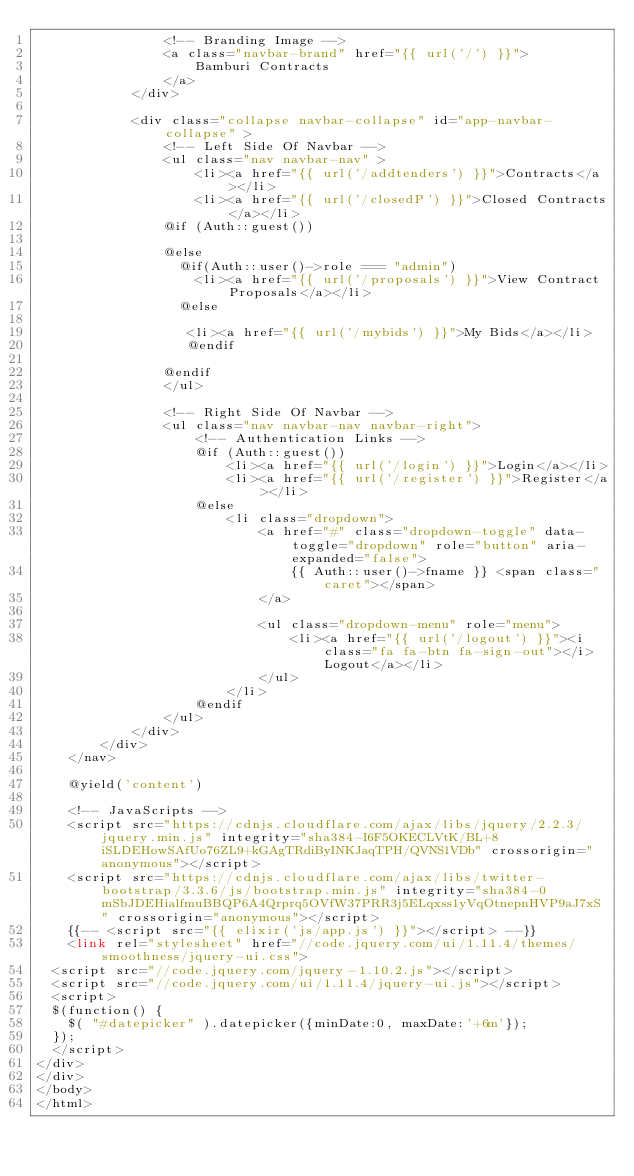Convert code to text. <code><loc_0><loc_0><loc_500><loc_500><_PHP_>                <!-- Branding Image -->
                <a class="navbar-brand" href="{{ url('/') }}">
                    Bamburi Contracts
                </a>
            </div>

            <div class="collapse navbar-collapse" id="app-navbar-collapse" >
                <!-- Left Side Of Navbar -->
                <ul class="nav navbar-nav" >
                    <li><a href="{{ url('/addtenders') }}">Contracts</a></li>
                    <li><a href="{{ url('/closedP') }}">Closed Contracts</a></li>
                @if (Auth::guest())

                @else
                  @if(Auth::user()->role === "admin")
                    <li><a href="{{ url('/proposals') }}">View Contract Proposals</a></li>
                  @else

                   <li><a href="{{ url('/mybids') }}">My Bids</a></li>
                   @endif

                @endif
                </ul>

                <!-- Right Side Of Navbar -->
                <ul class="nav navbar-nav navbar-right">
                    <!-- Authentication Links -->
                    @if (Auth::guest())
                        <li><a href="{{ url('/login') }}">Login</a></li>
                        <li><a href="{{ url('/register') }}">Register</a></li>
                    @else
                        <li class="dropdown">
                            <a href="#" class="dropdown-toggle" data-toggle="dropdown" role="button" aria-expanded="false">
                                {{ Auth::user()->fname }} <span class="caret"></span>
                            </a>

                            <ul class="dropdown-menu" role="menu">
                                <li><a href="{{ url('/logout') }}"><i class="fa fa-btn fa-sign-out"></i>Logout</a></li>
                            </ul>
                        </li>
                    @endif
                </ul>
            </div>
        </div>
    </nav>

    @yield('content')

    <!-- JavaScripts -->
    <script src="https://cdnjs.cloudflare.com/ajax/libs/jquery/2.2.3/jquery.min.js" integrity="sha384-I6F5OKECLVtK/BL+8iSLDEHowSAfUo76ZL9+kGAgTRdiByINKJaqTPH/QVNS1VDb" crossorigin="anonymous"></script>
    <script src="https://cdnjs.cloudflare.com/ajax/libs/twitter-bootstrap/3.3.6/js/bootstrap.min.js" integrity="sha384-0mSbJDEHialfmuBBQP6A4Qrprq5OVfW37PRR3j5ELqxss1yVqOtnepnHVP9aJ7xS" crossorigin="anonymous"></script>
    {{-- <script src="{{ elixir('js/app.js') }}"></script> --}}
    <link rel="stylesheet" href="//code.jquery.com/ui/1.11.4/themes/smoothness/jquery-ui.css">
  <script src="//code.jquery.com/jquery-1.10.2.js"></script>
  <script src="//code.jquery.com/ui/1.11.4/jquery-ui.js"></script>
  <script>
  $(function() {
    $( "#datepicker" ).datepicker({minDate:0, maxDate:'+6m'});
  });
  </script>
</div>
</div>
</body>
</html>
</code> 